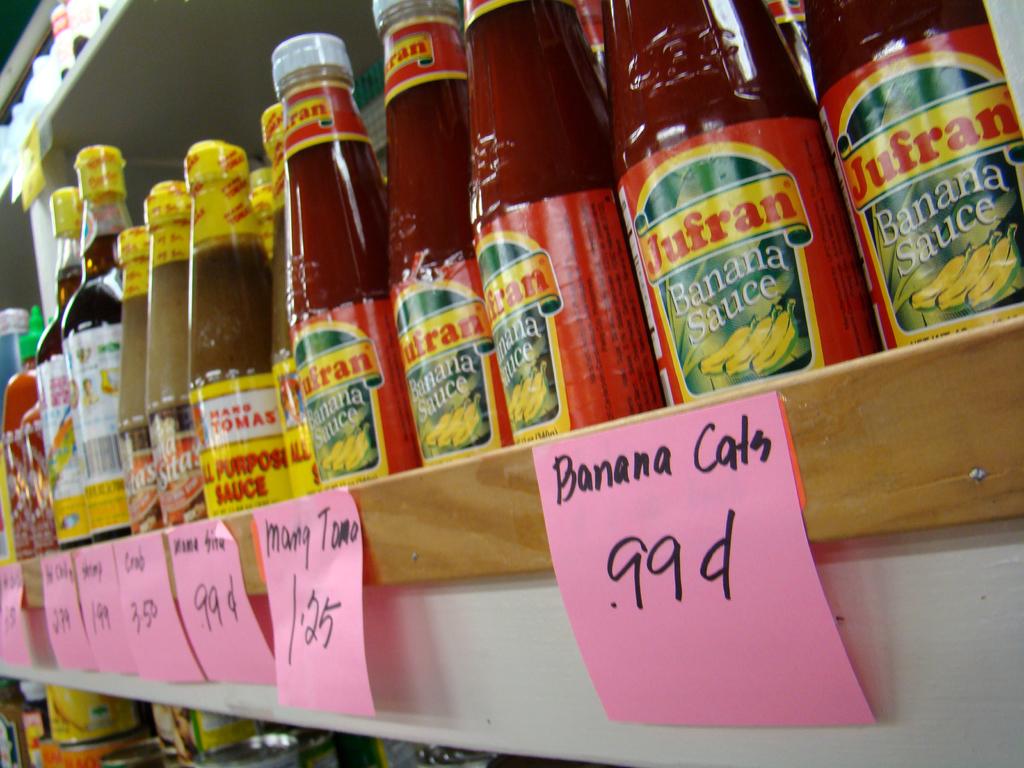What type of sauce is this?
Offer a terse response. Banana. How much is the banana sauce?
Offer a very short reply. 99 cents. 